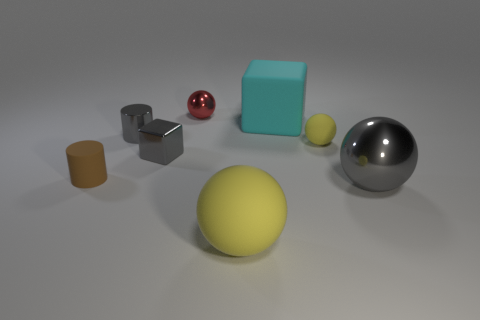Subtract 1 balls. How many balls are left? 3 Add 2 cyan rubber objects. How many objects exist? 10 Subtract all blocks. How many objects are left? 6 Subtract all brown matte cylinders. Subtract all tiny rubber things. How many objects are left? 5 Add 4 tiny metallic spheres. How many tiny metallic spheres are left? 5 Add 3 small gray shiny cylinders. How many small gray shiny cylinders exist? 4 Subtract 0 green cylinders. How many objects are left? 8 